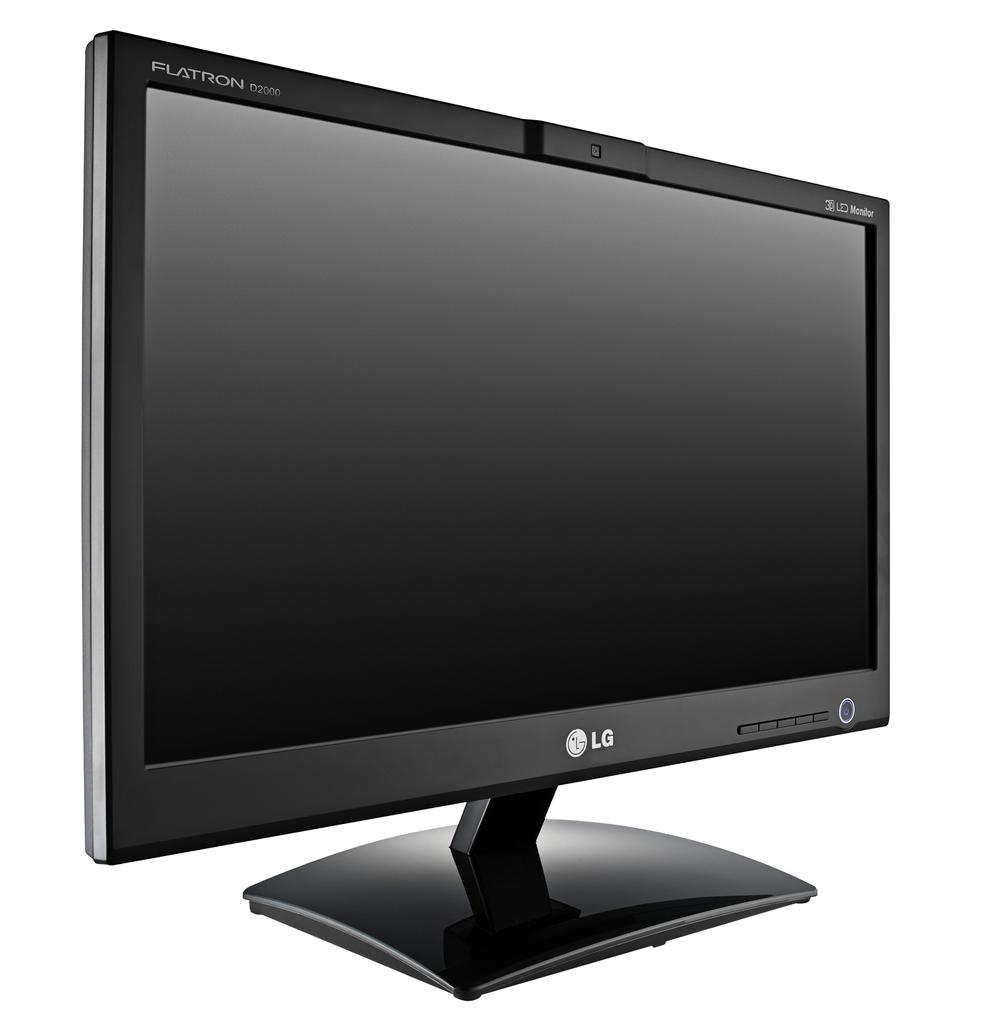<image>
Offer a succinct explanation of the picture presented. A black LG FLatron monitor with a white background. 